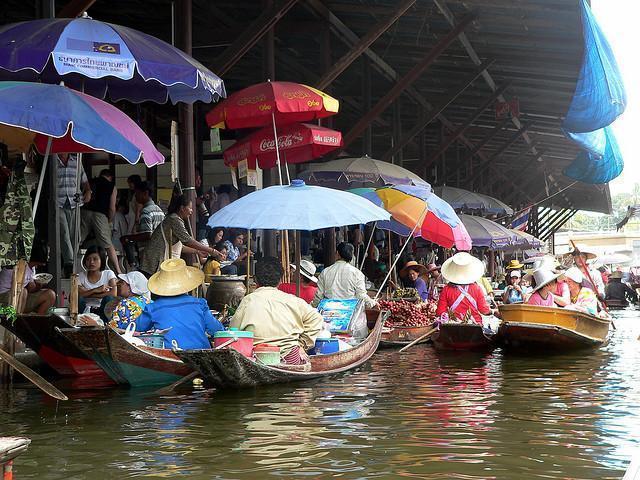What is the woman with a big blue umbrella doing?
From the following four choices, select the correct answer to address the question.
Options: Sightseeing, boat racing, commuting, selling stuff. Selling stuff. 